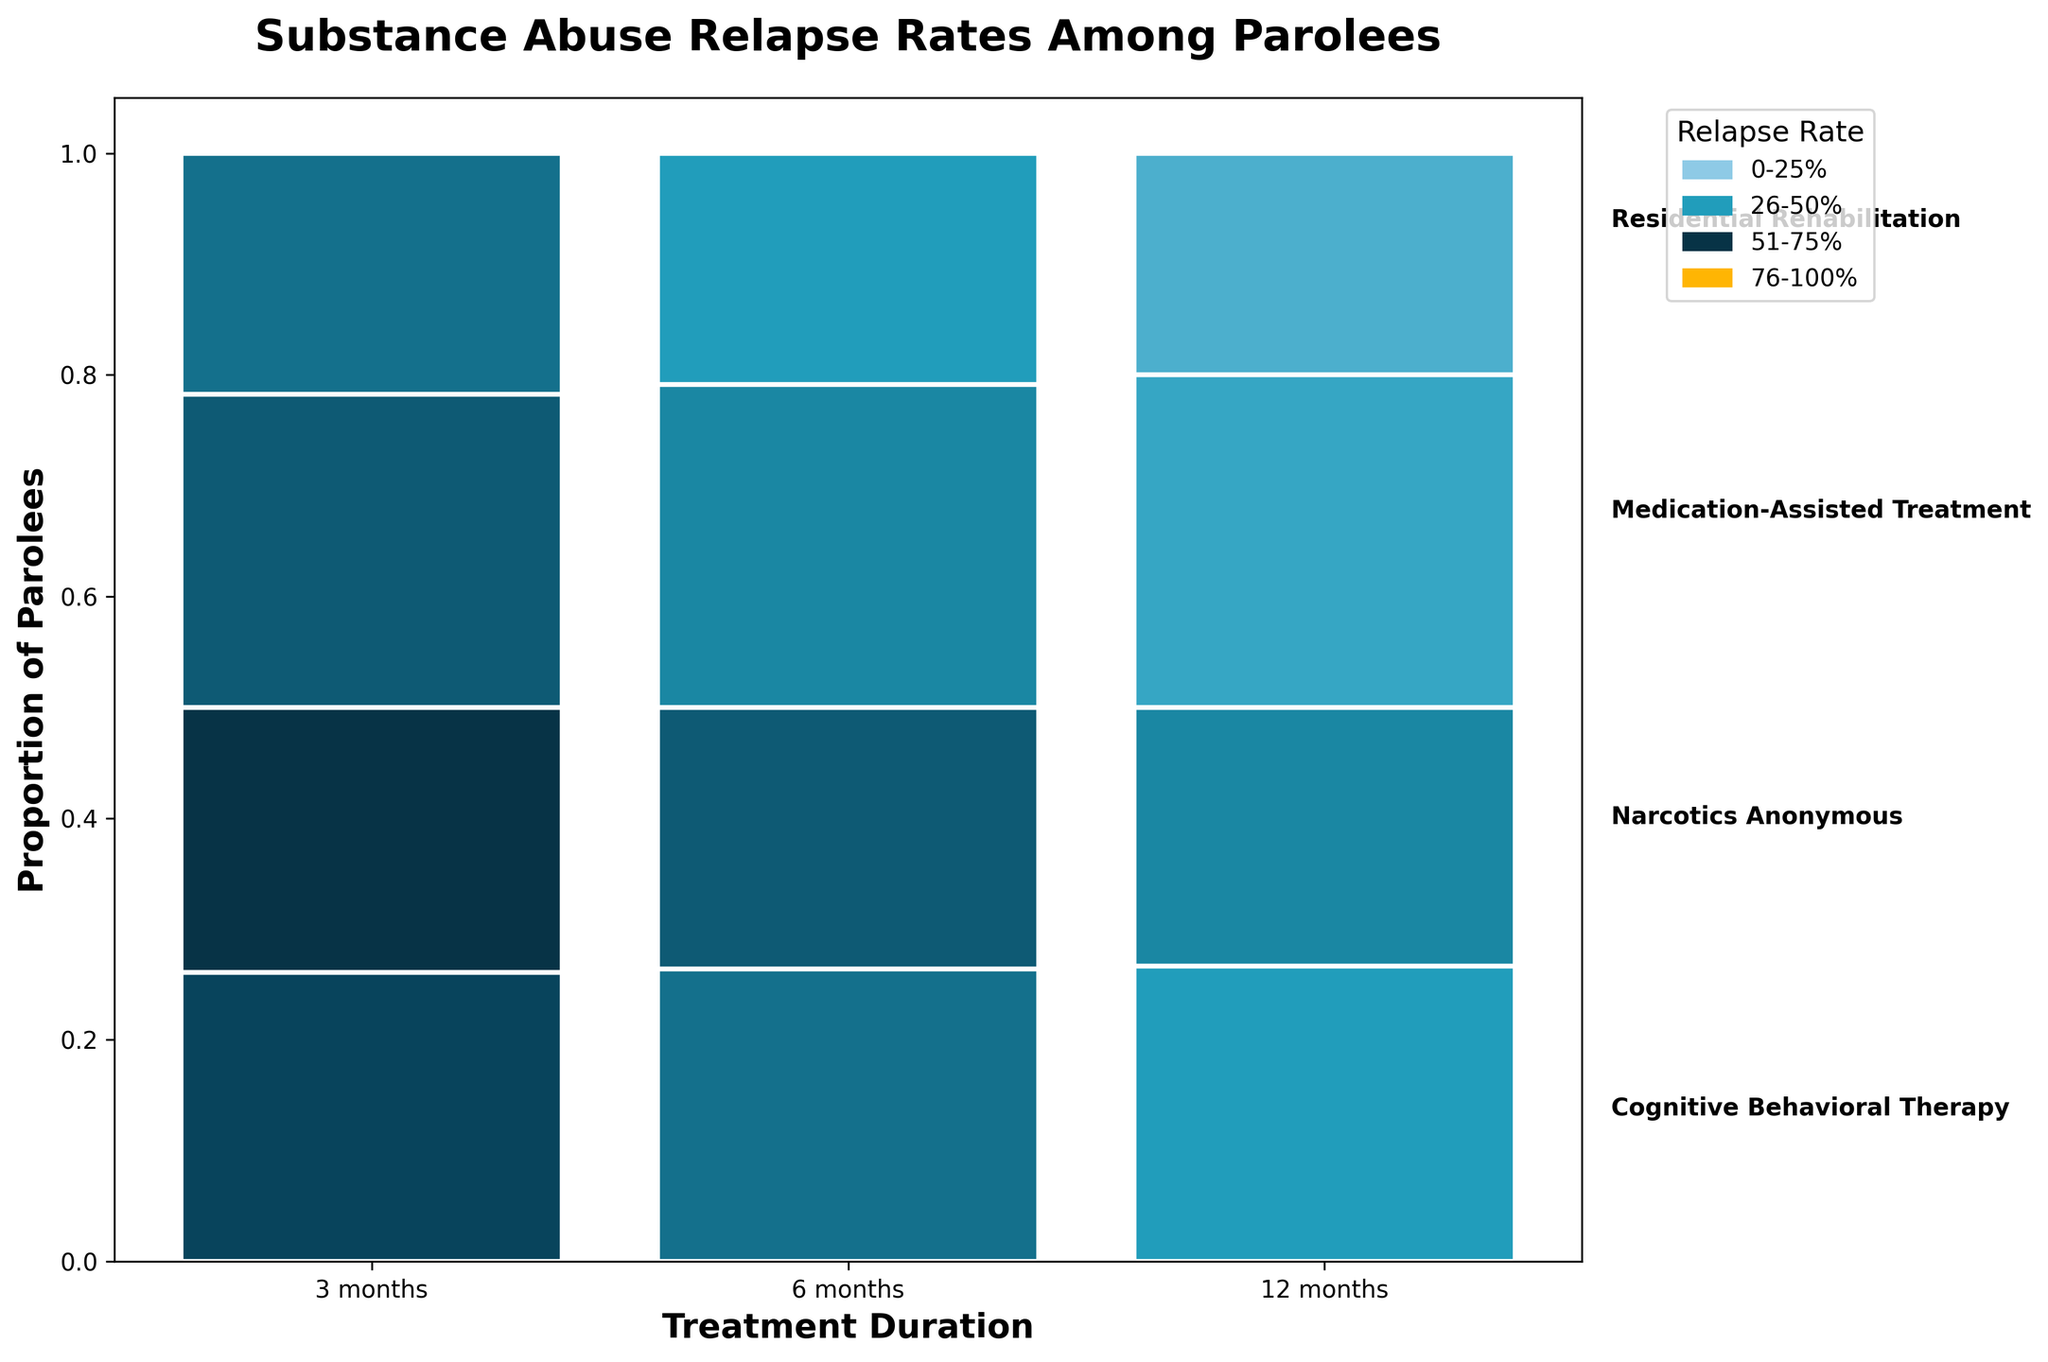What is the title of the plot? The title is usually located at the top of the plot. For this mosaic plot, the title is "Substance Abuse Relapse Rates Among Parolees."
Answer: Substance Abuse Relapse Rates Among Parolees What does the color legend represent? The color legend, typically located on the side of the plot, shows different shades representing different relapse rates ranges. These ranges are generally in percentages.
Answer: Relapse Rate How many treatment durations are represented in the plot? Treatment durations are indicated on the x-axis. The available durations are typically listed in the axis labels.
Answer: 3 What is the total number of parolees depicted in this plot? To get the total number, sum the 'Number of Parolees' across all treatments and durations. (120+95+80+110+85+70+130+105+90+100+75+60)
Answer: 1120 What's the average relapse rate for 12-month durations across all treatment types? Find the relapse rates for 12-month durations for each treatment type, sum them up, and divide by the number of treatment types. (25% + 30% + 20% + 15%) / 4
Answer: 22.5% Which treatment type shows the lowest relapse rate for a 6-month duration? Compare the relapse rates at 6 months for each treatment type (35% for Cognitive Behavioral Therapy, 40% for Narcotics Anonymous, 30% for Medication-Assisted Treatment, 25% for Residential Rehabilitation).
Answer: Residential Rehabilitation Which treatment type has the highest number of parolees for a 3-month duration? Look at the numbers in the 'Number of Parolees' column for the 3-month duration for each treatment type (120, 110, 130, 100).
Answer: Medication-Assisted Treatment How does the relapse rate for Narcotics Anonymous at 12 months compare to Cognitive Behavioral Therapy at 6 months? Compare the relapse rates directly (30% for Narcotics Anonymous at 12 months vs. 35% for Cognitive Behavioral Therapy at 6 months).
Answer: Lower How are the proportions of parolees distributed among different treatment durations in the plot? The heights of the bars represent the proportions of parolees. The combined height of all bars for each treatment duration will equal 1, but within that, you can see how much each treatment type contributes.
Answer: Varies across treatments What does the position of different colors within the bars tell you? The position of different colors (shades) within the bars indicates the relapse rate associated with each treatment type and duration combination. Lighter or darker shades can tell higher or lower relapse rates respectively.
Answer: Higher or lower relapse rates 